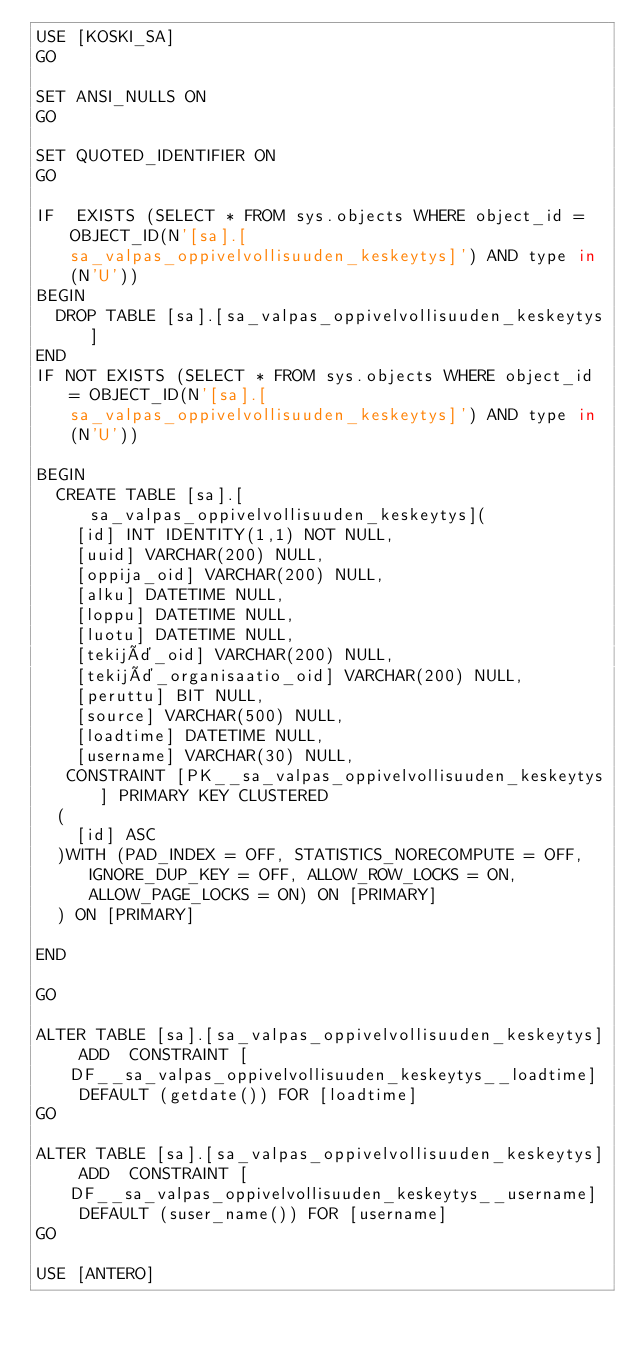Convert code to text. <code><loc_0><loc_0><loc_500><loc_500><_SQL_>USE [KOSKI_SA]
GO

SET ANSI_NULLS ON
GO

SET QUOTED_IDENTIFIER ON
GO

IF  EXISTS (SELECT * FROM sys.objects WHERE object_id = OBJECT_ID(N'[sa].[sa_valpas_oppivelvollisuuden_keskeytys]') AND type in (N'U'))
BEGIN
	DROP TABLE [sa].[sa_valpas_oppivelvollisuuden_keskeytys]
END
IF NOT EXISTS (SELECT * FROM sys.objects WHERE object_id = OBJECT_ID(N'[sa].[sa_valpas_oppivelvollisuuden_keskeytys]') AND type in (N'U'))

BEGIN
	CREATE TABLE [sa].[sa_valpas_oppivelvollisuuden_keskeytys](
		[id] INT IDENTITY(1,1) NOT NULL,
		[uuid] VARCHAR(200) NULL,
		[oppija_oid] VARCHAR(200) NULL,
		[alku] DATETIME NULL,
		[loppu] DATETIME NULL,
		[luotu] DATETIME NULL,
		[tekijä_oid] VARCHAR(200) NULL,
		[tekijä_organisaatio_oid] VARCHAR(200) NULL,
		[peruttu] BIT NULL,
		[source] VARCHAR(500) NULL,
		[loadtime] DATETIME NULL,
		[username] VARCHAR(30) NULL,
	 CONSTRAINT [PK__sa_valpas_oppivelvollisuuden_keskeytys] PRIMARY KEY CLUSTERED
	(
		[id] ASC
	)WITH (PAD_INDEX = OFF, STATISTICS_NORECOMPUTE = OFF, IGNORE_DUP_KEY = OFF, ALLOW_ROW_LOCKS = ON, ALLOW_PAGE_LOCKS = ON) ON [PRIMARY]
	) ON [PRIMARY]

END

GO

ALTER TABLE [sa].[sa_valpas_oppivelvollisuuden_keskeytys] ADD  CONSTRAINT [DF__sa_valpas_oppivelvollisuuden_keskeytys__loadtime]  DEFAULT (getdate()) FOR [loadtime]
GO

ALTER TABLE [sa].[sa_valpas_oppivelvollisuuden_keskeytys] ADD  CONSTRAINT [DF__sa_valpas_oppivelvollisuuden_keskeytys__username]  DEFAULT (suser_name()) FOR [username]
GO

USE [ANTERO]
</code> 